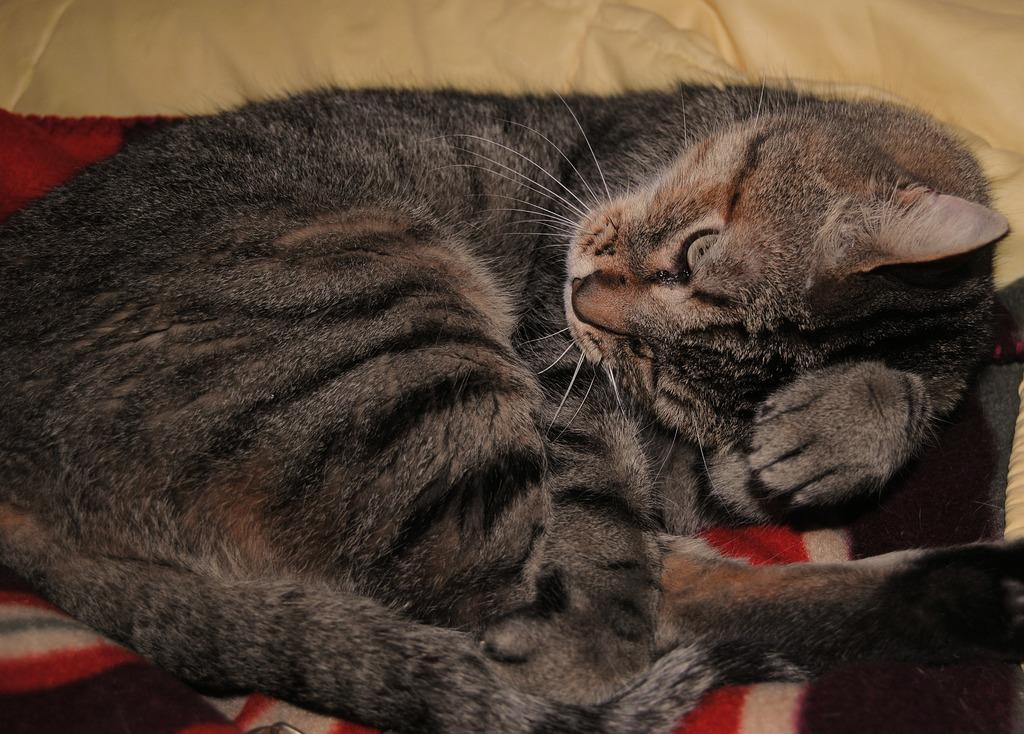What animal can be seen in the image? There is a cat in the image. What is the cat doing in the image? The cat is sleeping. Where is the cat located in the image? The cat is on a couch. What is the cause of the sun's appearance in the image? There is no sun present in the image, so it cannot be determined what might cause its appearance. 